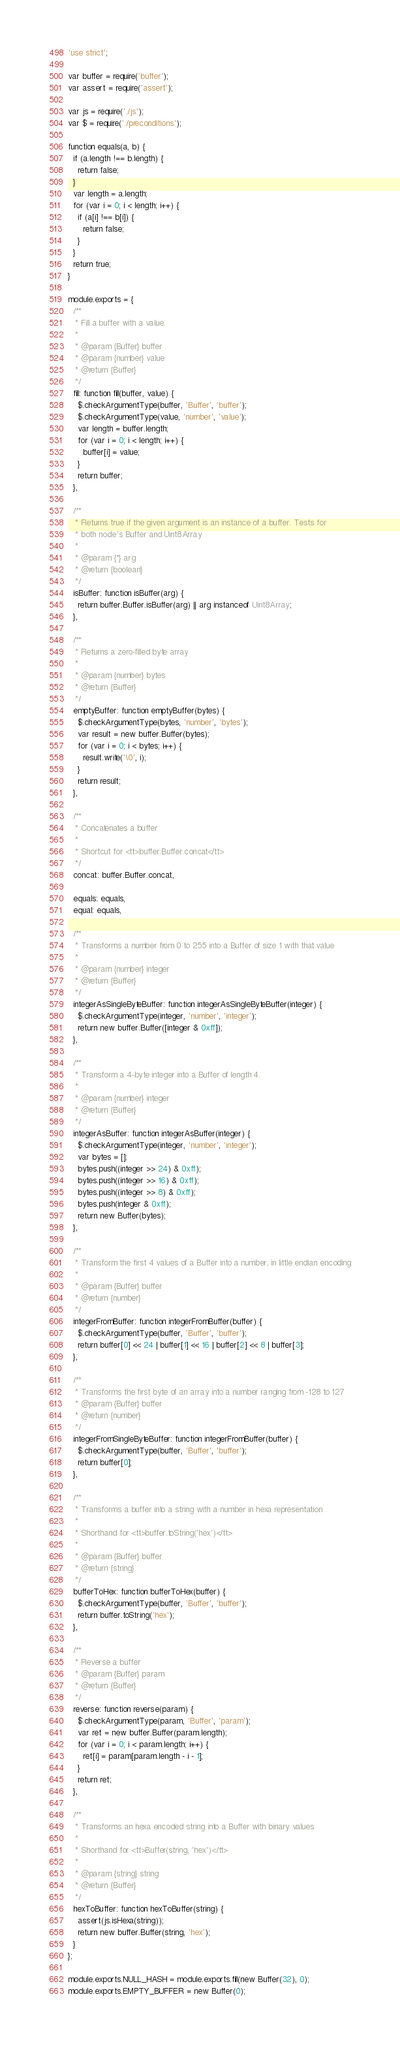Convert code to text. <code><loc_0><loc_0><loc_500><loc_500><_JavaScript_>'use strict';

var buffer = require('buffer');
var assert = require('assert');

var js = require('./js');
var $ = require('./preconditions');

function equals(a, b) {
  if (a.length !== b.length) {
    return false;
  }
  var length = a.length;
  for (var i = 0; i < length; i++) {
    if (a[i] !== b[i]) {
      return false;
    }
  }
  return true;
}

module.exports = {
  /**
   * Fill a buffer with a value.
   *
   * @param {Buffer} buffer
   * @param {number} value
   * @return {Buffer}
   */
  fill: function fill(buffer, value) {
    $.checkArgumentType(buffer, 'Buffer', 'buffer');
    $.checkArgumentType(value, 'number', 'value');
    var length = buffer.length;
    for (var i = 0; i < length; i++) {
      buffer[i] = value;
    }
    return buffer;
  },

  /**
   * Returns true if the given argument is an instance of a buffer. Tests for
   * both node's Buffer and Uint8Array
   *
   * @param {*} arg
   * @return {boolean}
   */
  isBuffer: function isBuffer(arg) {
    return buffer.Buffer.isBuffer(arg) || arg instanceof Uint8Array;
  },

  /**
   * Returns a zero-filled byte array
   *
   * @param {number} bytes
   * @return {Buffer}
   */
  emptyBuffer: function emptyBuffer(bytes) {
    $.checkArgumentType(bytes, 'number', 'bytes');
    var result = new buffer.Buffer(bytes);
    for (var i = 0; i < bytes; i++) {
      result.write('\0', i);
    }
    return result;
  },

  /**
   * Concatenates a buffer
   *
   * Shortcut for <tt>buffer.Buffer.concat</tt>
   */
  concat: buffer.Buffer.concat,

  equals: equals,
  equal: equals,

  /**
   * Transforms a number from 0 to 255 into a Buffer of size 1 with that value
   *
   * @param {number} integer
   * @return {Buffer}
   */
  integerAsSingleByteBuffer: function integerAsSingleByteBuffer(integer) {
    $.checkArgumentType(integer, 'number', 'integer');
    return new buffer.Buffer([integer & 0xff]);
  },

  /**
   * Transform a 4-byte integer into a Buffer of length 4.
   *
   * @param {number} integer
   * @return {Buffer}
   */
  integerAsBuffer: function integerAsBuffer(integer) {
    $.checkArgumentType(integer, 'number', 'integer');
    var bytes = [];
    bytes.push((integer >> 24) & 0xff);
    bytes.push((integer >> 16) & 0xff);
    bytes.push((integer >> 8) & 0xff);
    bytes.push(integer & 0xff);
    return new Buffer(bytes);
  },

  /**
   * Transform the first 4 values of a Buffer into a number, in little endian encoding
   *
   * @param {Buffer} buffer
   * @return {number}
   */
  integerFromBuffer: function integerFromBuffer(buffer) {
    $.checkArgumentType(buffer, 'Buffer', 'buffer');
    return buffer[0] << 24 | buffer[1] << 16 | buffer[2] << 8 | buffer[3];
  },

  /**
   * Transforms the first byte of an array into a number ranging from -128 to 127
   * @param {Buffer} buffer
   * @return {number}
   */
  integerFromSingleByteBuffer: function integerFromBuffer(buffer) {
    $.checkArgumentType(buffer, 'Buffer', 'buffer');
    return buffer[0];
  },

  /**
   * Transforms a buffer into a string with a number in hexa representation
   *
   * Shorthand for <tt>buffer.toString('hex')</tt>
   *
   * @param {Buffer} buffer
   * @return {string}
   */
  bufferToHex: function bufferToHex(buffer) {
    $.checkArgumentType(buffer, 'Buffer', 'buffer');
    return buffer.toString('hex');
  },

  /**
   * Reverse a buffer
   * @param {Buffer} param
   * @return {Buffer}
   */
  reverse: function reverse(param) {
    $.checkArgumentType(param, 'Buffer', 'param');
    var ret = new buffer.Buffer(param.length);
    for (var i = 0; i < param.length; i++) {
      ret[i] = param[param.length - i - 1];
    }
    return ret;
  },

  /**
   * Transforms an hexa encoded string into a Buffer with binary values
   *
   * Shorthand for <tt>Buffer(string, 'hex')</tt>
   *
   * @param {string} string
   * @return {Buffer}
   */
  hexToBuffer: function hexToBuffer(string) {
    assert(js.isHexa(string));
    return new buffer.Buffer(string, 'hex');
  }
};

module.exports.NULL_HASH = module.exports.fill(new Buffer(32), 0);
module.exports.EMPTY_BUFFER = new Buffer(0);
</code> 